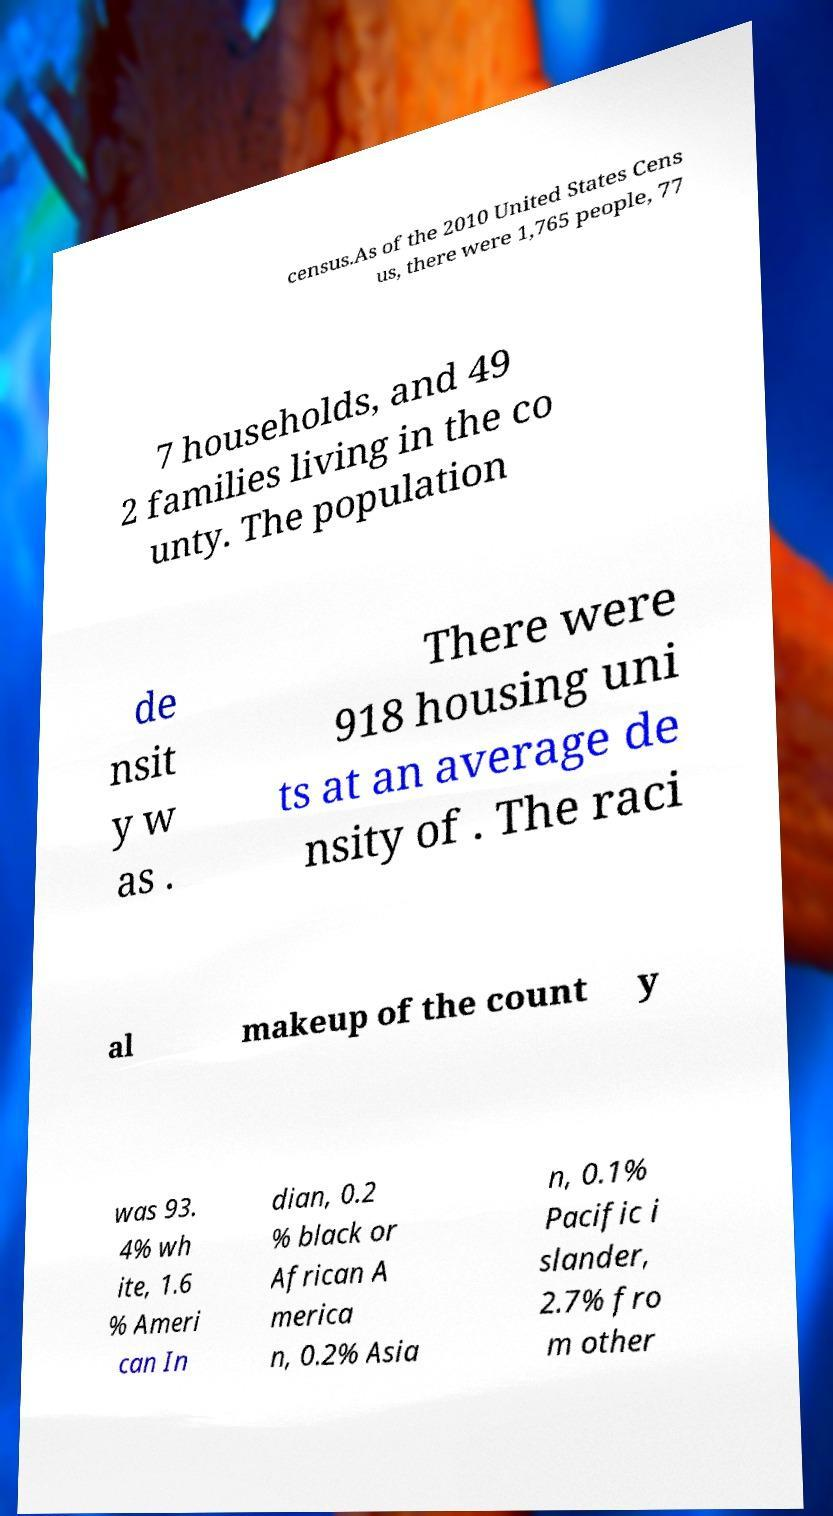What messages or text are displayed in this image? I need them in a readable, typed format. census.As of the 2010 United States Cens us, there were 1,765 people, 77 7 households, and 49 2 families living in the co unty. The population de nsit y w as . There were 918 housing uni ts at an average de nsity of . The raci al makeup of the count y was 93. 4% wh ite, 1.6 % Ameri can In dian, 0.2 % black or African A merica n, 0.2% Asia n, 0.1% Pacific i slander, 2.7% fro m other 